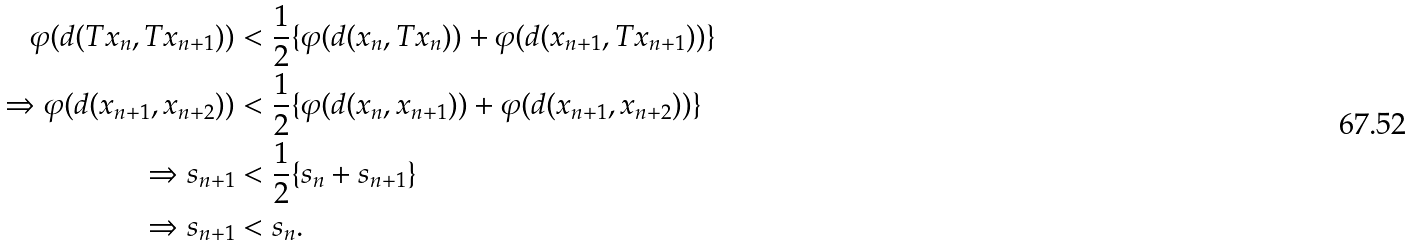Convert formula to latex. <formula><loc_0><loc_0><loc_500><loc_500>\varphi ( d ( T x _ { n } , T x _ { n + 1 } ) ) & < \frac { 1 } { 2 } \{ \varphi ( d ( x _ { n } , T x _ { n } ) ) + \varphi ( d ( x _ { n + 1 } , T x _ { n + 1 } ) ) \} \\ \Rightarrow \varphi ( d ( x _ { n + 1 } , x _ { n + 2 } ) ) & < \frac { 1 } { 2 } \{ \varphi ( d ( x _ { n } , x _ { n + 1 } ) ) + \varphi ( d ( x _ { n + 1 } , x _ { n + 2 } ) ) \} \\ \Rightarrow s _ { n + 1 } & < \frac { 1 } { 2 } \{ s _ { n } + s _ { n + 1 } \} \\ \Rightarrow s _ { n + 1 } & < s _ { n } .</formula> 